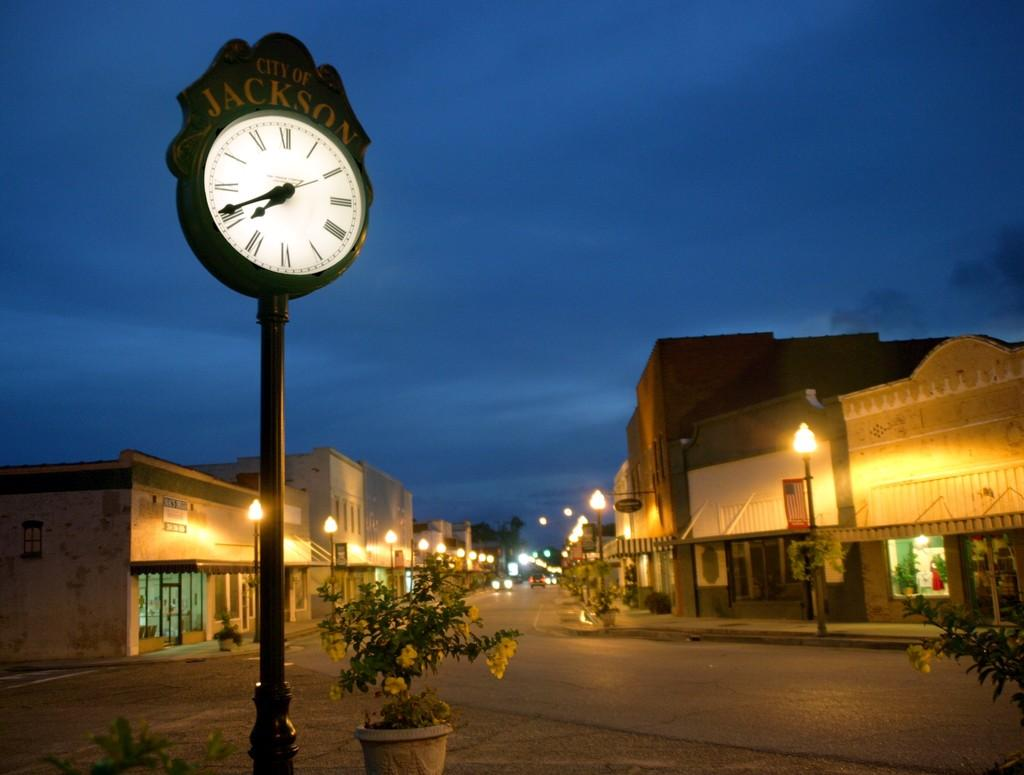<image>
Give a short and clear explanation of the subsequent image. A City of Jacksonlamp post clock shows time with an evening streetscape receding behind. 